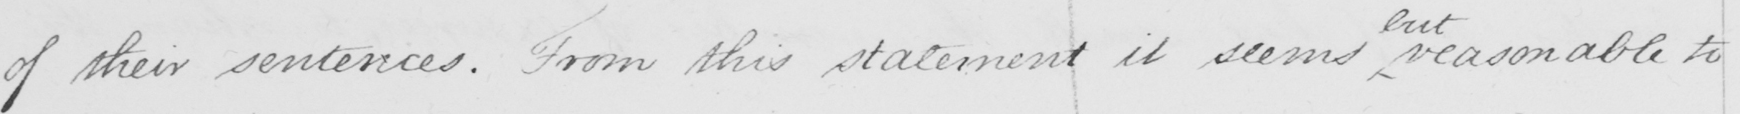What text is written in this handwritten line? of their sentences . From this statement it seemed reasonable to 